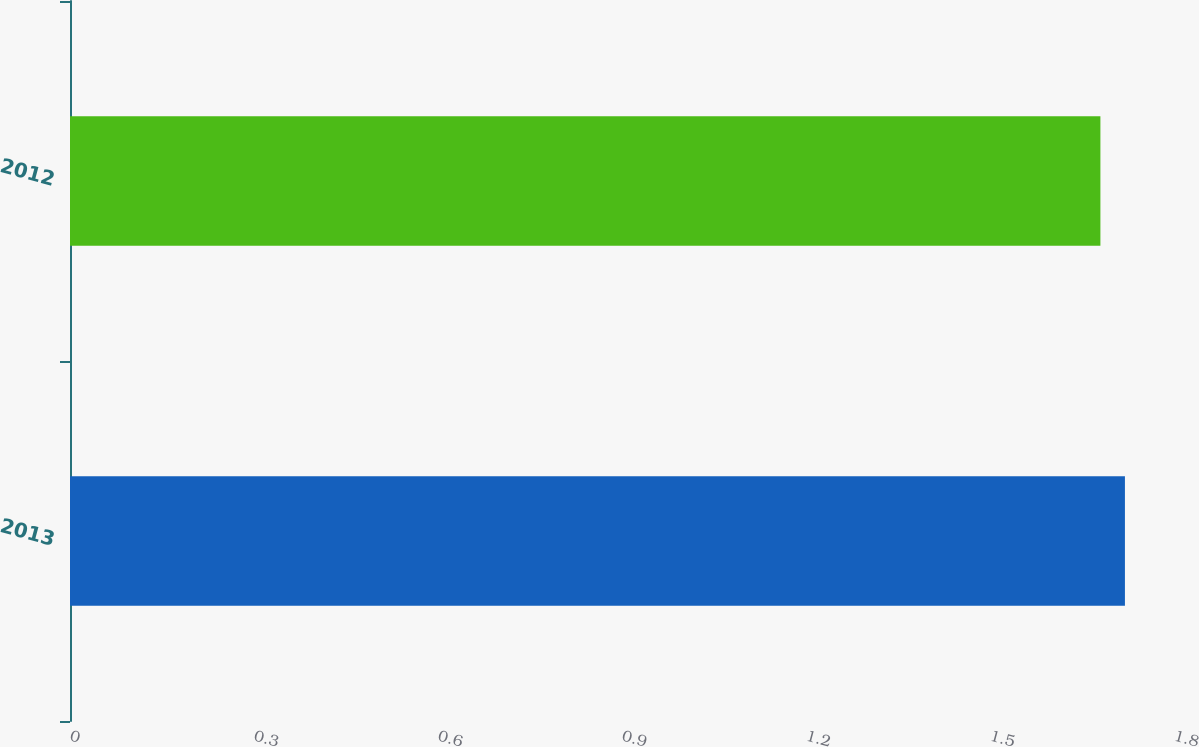<chart> <loc_0><loc_0><loc_500><loc_500><bar_chart><fcel>2013<fcel>2012<nl><fcel>1.72<fcel>1.68<nl></chart> 